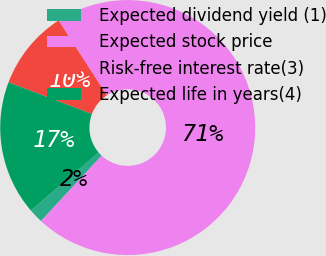<chart> <loc_0><loc_0><loc_500><loc_500><pie_chart><fcel>Expected dividend yield (1)<fcel>Expected stock price<fcel>Risk-free interest rate(3)<fcel>Expected life in years(4)<nl><fcel>1.83%<fcel>71.01%<fcel>10.11%<fcel>17.04%<nl></chart> 